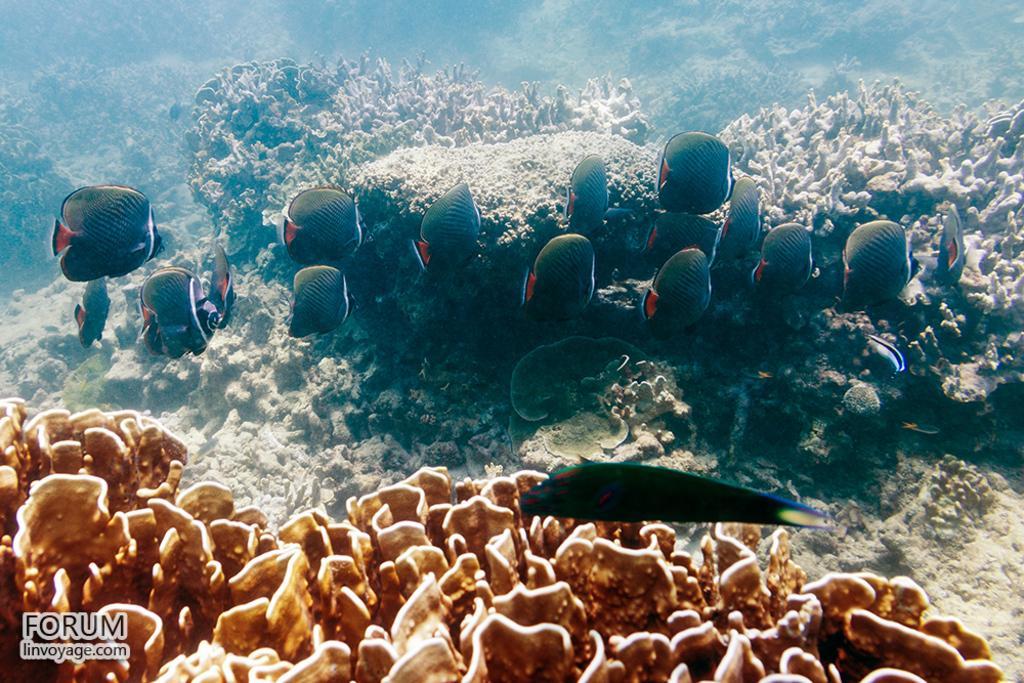In one or two sentences, can you explain what this image depicts? This is a picture clicked inside the water. In the foreground there are coral reefs. In the center of the picture we can see fishes, plants and coral reefs. 